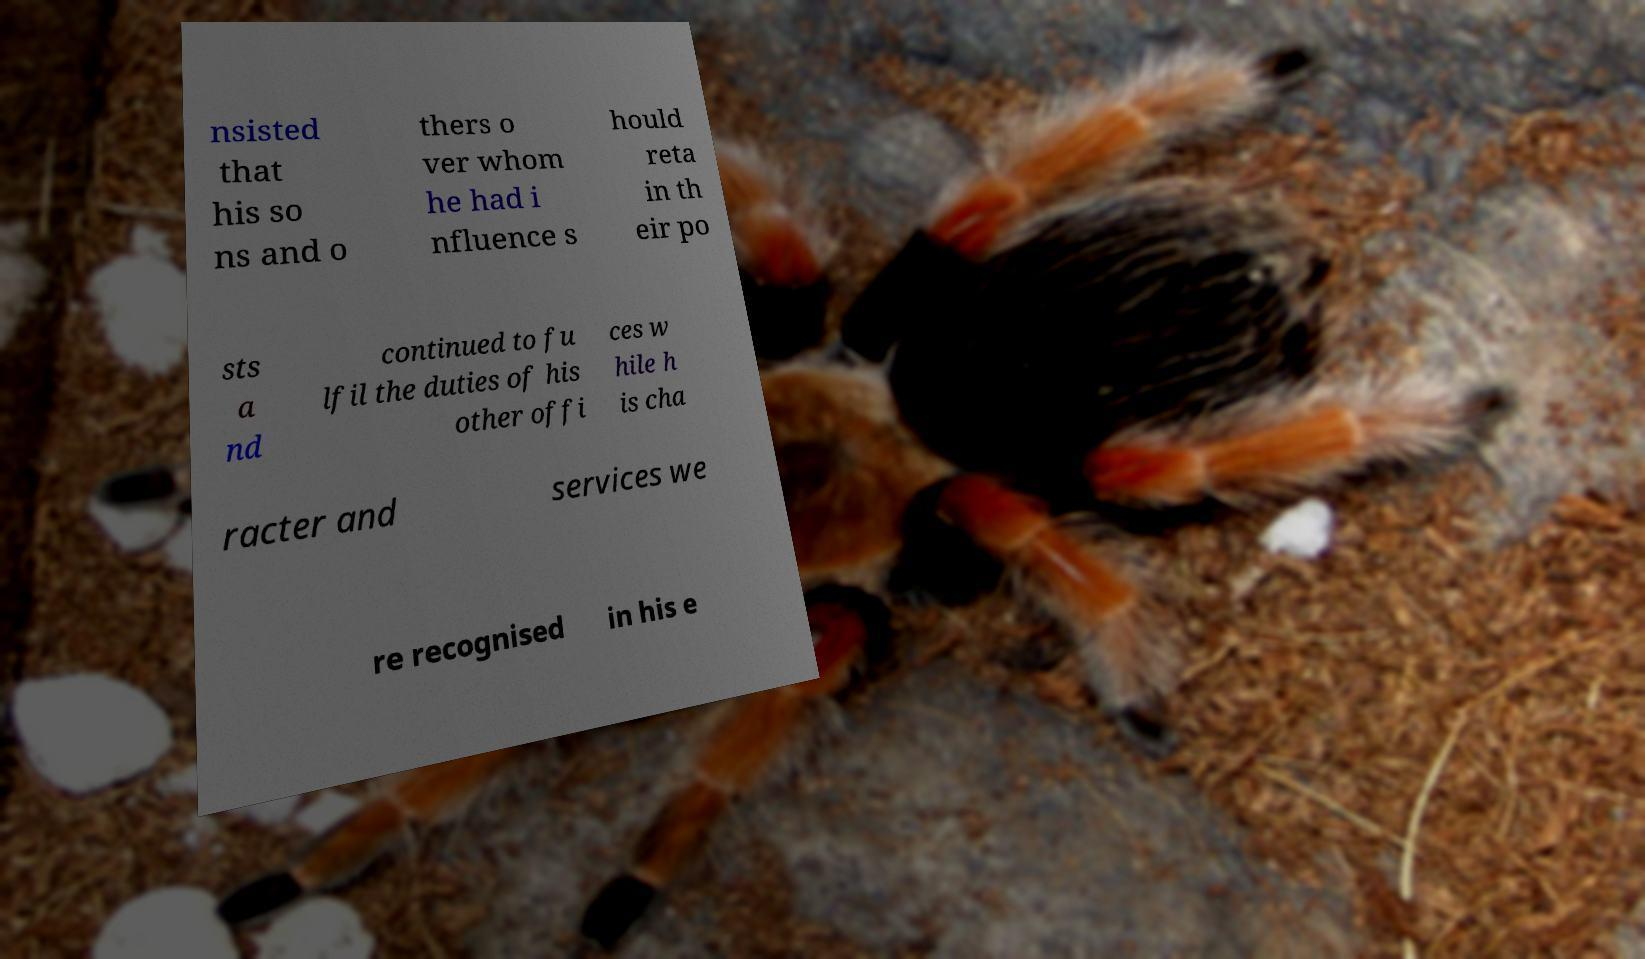Could you assist in decoding the text presented in this image and type it out clearly? nsisted that his so ns and o thers o ver whom he had i nfluence s hould reta in th eir po sts a nd continued to fu lfil the duties of his other offi ces w hile h is cha racter and services we re recognised in his e 